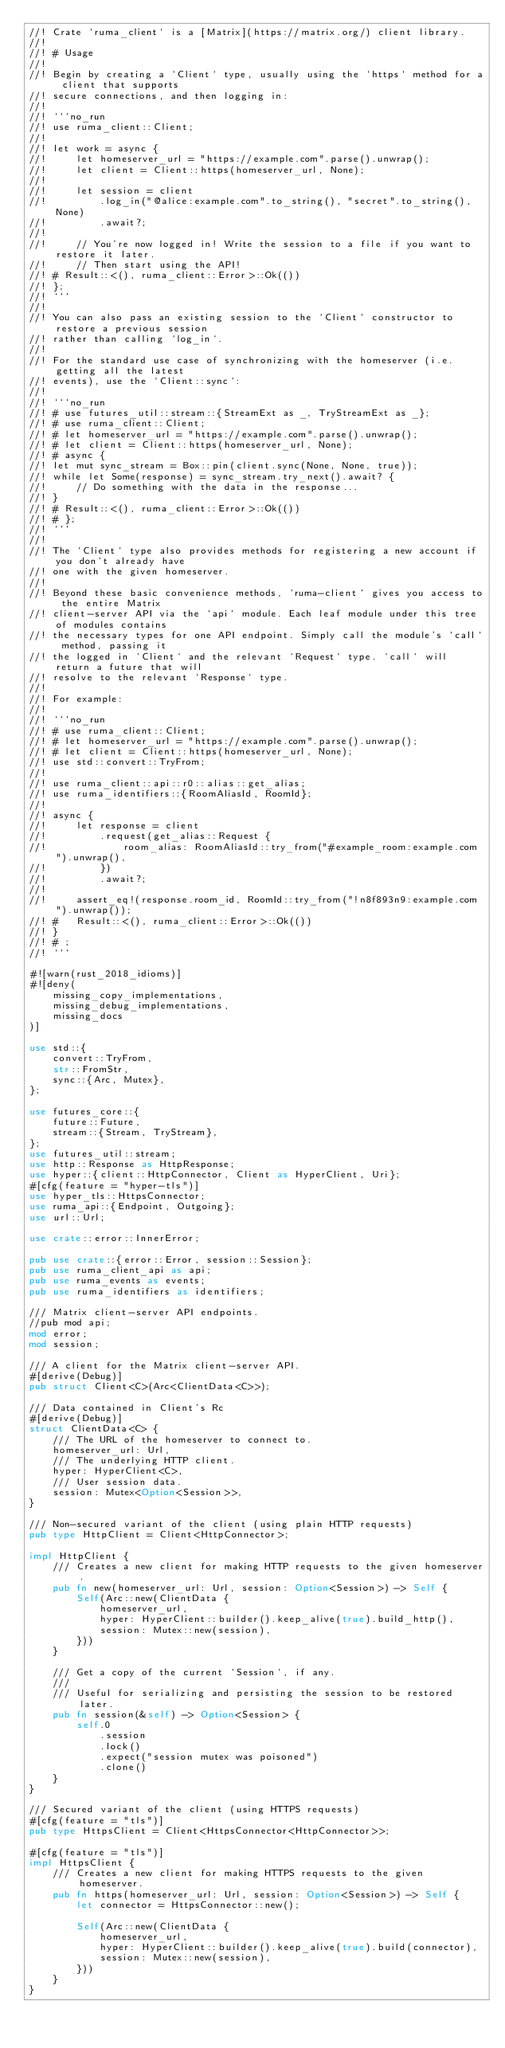Convert code to text. <code><loc_0><loc_0><loc_500><loc_500><_Rust_>//! Crate `ruma_client` is a [Matrix](https://matrix.org/) client library.
//!
//! # Usage
//!
//! Begin by creating a `Client` type, usually using the `https` method for a client that supports
//! secure connections, and then logging in:
//!
//! ```no_run
//! use ruma_client::Client;
//!
//! let work = async {
//!     let homeserver_url = "https://example.com".parse().unwrap();
//!     let client = Client::https(homeserver_url, None);
//!
//!     let session = client
//!         .log_in("@alice:example.com".to_string(), "secret".to_string(), None)
//!         .await?;
//!
//!     // You're now logged in! Write the session to a file if you want to restore it later.
//!     // Then start using the API!
//! # Result::<(), ruma_client::Error>::Ok(())
//! };
//! ```
//!
//! You can also pass an existing session to the `Client` constructor to restore a previous session
//! rather than calling `log_in`.
//!
//! For the standard use case of synchronizing with the homeserver (i.e. getting all the latest
//! events), use the `Client::sync`:
//!
//! ```no_run
//! # use futures_util::stream::{StreamExt as _, TryStreamExt as _};
//! # use ruma_client::Client;
//! # let homeserver_url = "https://example.com".parse().unwrap();
//! # let client = Client::https(homeserver_url, None);
//! # async {
//! let mut sync_stream = Box::pin(client.sync(None, None, true));
//! while let Some(response) = sync_stream.try_next().await? {
//!     // Do something with the data in the response...
//! }
//! # Result::<(), ruma_client::Error>::Ok(())
//! # };
//! ```
//!
//! The `Client` type also provides methods for registering a new account if you don't already have
//! one with the given homeserver.
//!
//! Beyond these basic convenience methods, `ruma-client` gives you access to the entire Matrix
//! client-server API via the `api` module. Each leaf module under this tree of modules contains
//! the necessary types for one API endpoint. Simply call the module's `call` method, passing it
//! the logged in `Client` and the relevant `Request` type. `call` will return a future that will
//! resolve to the relevant `Response` type.
//!
//! For example:
//!
//! ```no_run
//! # use ruma_client::Client;
//! # let homeserver_url = "https://example.com".parse().unwrap();
//! # let client = Client::https(homeserver_url, None);
//! use std::convert::TryFrom;
//!
//! use ruma_client::api::r0::alias::get_alias;
//! use ruma_identifiers::{RoomAliasId, RoomId};
//!
//! async {
//!     let response = client
//!         .request(get_alias::Request {
//!             room_alias: RoomAliasId::try_from("#example_room:example.com").unwrap(),
//!         })
//!         .await?;
//!
//!     assert_eq!(response.room_id, RoomId::try_from("!n8f893n9:example.com").unwrap());
//! #   Result::<(), ruma_client::Error>::Ok(())
//! }
//! # ;
//! ```

#![warn(rust_2018_idioms)]
#![deny(
    missing_copy_implementations,
    missing_debug_implementations,
    missing_docs
)]

use std::{
    convert::TryFrom,
    str::FromStr,
    sync::{Arc, Mutex},
};

use futures_core::{
    future::Future,
    stream::{Stream, TryStream},
};
use futures_util::stream;
use http::Response as HttpResponse;
use hyper::{client::HttpConnector, Client as HyperClient, Uri};
#[cfg(feature = "hyper-tls")]
use hyper_tls::HttpsConnector;
use ruma_api::{Endpoint, Outgoing};
use url::Url;

use crate::error::InnerError;

pub use crate::{error::Error, session::Session};
pub use ruma_client_api as api;
pub use ruma_events as events;
pub use ruma_identifiers as identifiers;

/// Matrix client-server API endpoints.
//pub mod api;
mod error;
mod session;

/// A client for the Matrix client-server API.
#[derive(Debug)]
pub struct Client<C>(Arc<ClientData<C>>);

/// Data contained in Client's Rc
#[derive(Debug)]
struct ClientData<C> {
    /// The URL of the homeserver to connect to.
    homeserver_url: Url,
    /// The underlying HTTP client.
    hyper: HyperClient<C>,
    /// User session data.
    session: Mutex<Option<Session>>,
}

/// Non-secured variant of the client (using plain HTTP requests)
pub type HttpClient = Client<HttpConnector>;

impl HttpClient {
    /// Creates a new client for making HTTP requests to the given homeserver.
    pub fn new(homeserver_url: Url, session: Option<Session>) -> Self {
        Self(Arc::new(ClientData {
            homeserver_url,
            hyper: HyperClient::builder().keep_alive(true).build_http(),
            session: Mutex::new(session),
        }))
    }

    /// Get a copy of the current `Session`, if any.
    ///
    /// Useful for serializing and persisting the session to be restored later.
    pub fn session(&self) -> Option<Session> {
        self.0
            .session
            .lock()
            .expect("session mutex was poisoned")
            .clone()
    }
}

/// Secured variant of the client (using HTTPS requests)
#[cfg(feature = "tls")]
pub type HttpsClient = Client<HttpsConnector<HttpConnector>>;

#[cfg(feature = "tls")]
impl HttpsClient {
    /// Creates a new client for making HTTPS requests to the given homeserver.
    pub fn https(homeserver_url: Url, session: Option<Session>) -> Self {
        let connector = HttpsConnector::new();

        Self(Arc::new(ClientData {
            homeserver_url,
            hyper: HyperClient::builder().keep_alive(true).build(connector),
            session: Mutex::new(session),
        }))
    }
}
</code> 